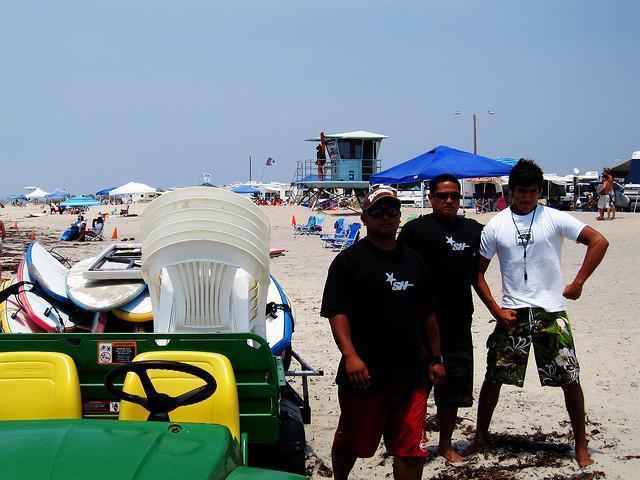How many of them are wearing shorts?
Give a very brief answer. 3. How many people are in the picture?
Give a very brief answer. 3. 